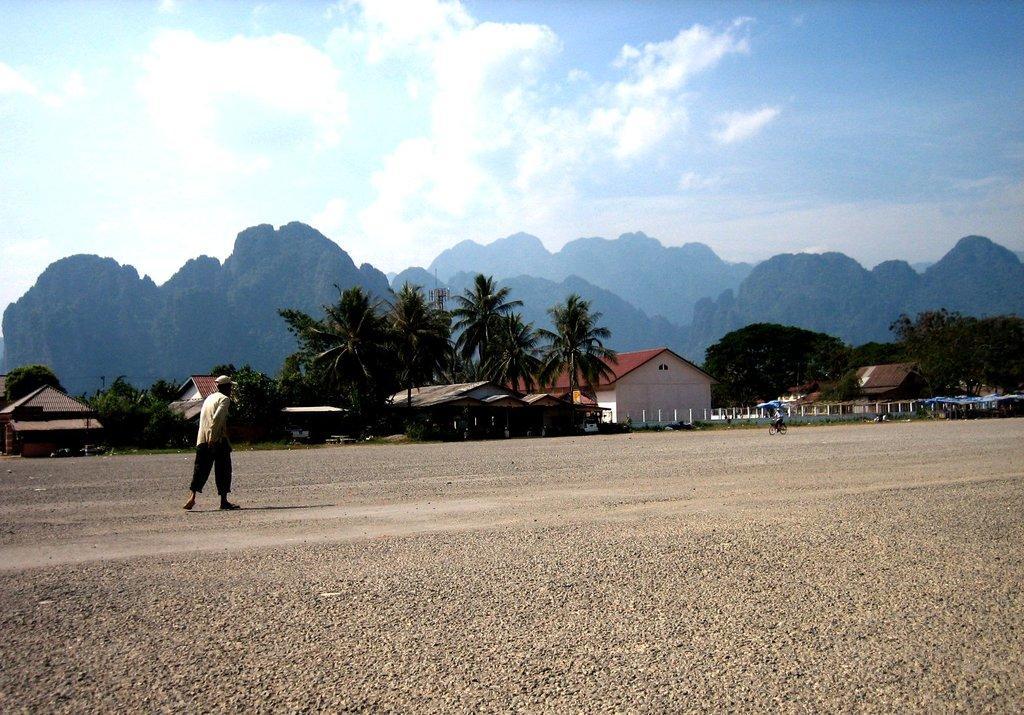Please provide a concise description of this image. In this image we can see there is a person riding bicycle and the other person walking on the ground. And at the back there are houses, trees and the cloudy sky. And at the side, it looks like a shed. 